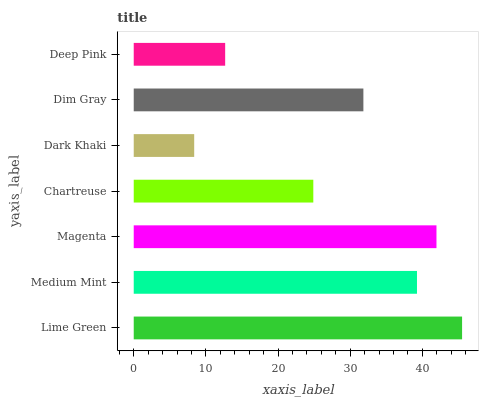Is Dark Khaki the minimum?
Answer yes or no. Yes. Is Lime Green the maximum?
Answer yes or no. Yes. Is Medium Mint the minimum?
Answer yes or no. No. Is Medium Mint the maximum?
Answer yes or no. No. Is Lime Green greater than Medium Mint?
Answer yes or no. Yes. Is Medium Mint less than Lime Green?
Answer yes or no. Yes. Is Medium Mint greater than Lime Green?
Answer yes or no. No. Is Lime Green less than Medium Mint?
Answer yes or no. No. Is Dim Gray the high median?
Answer yes or no. Yes. Is Dim Gray the low median?
Answer yes or no. Yes. Is Magenta the high median?
Answer yes or no. No. Is Magenta the low median?
Answer yes or no. No. 